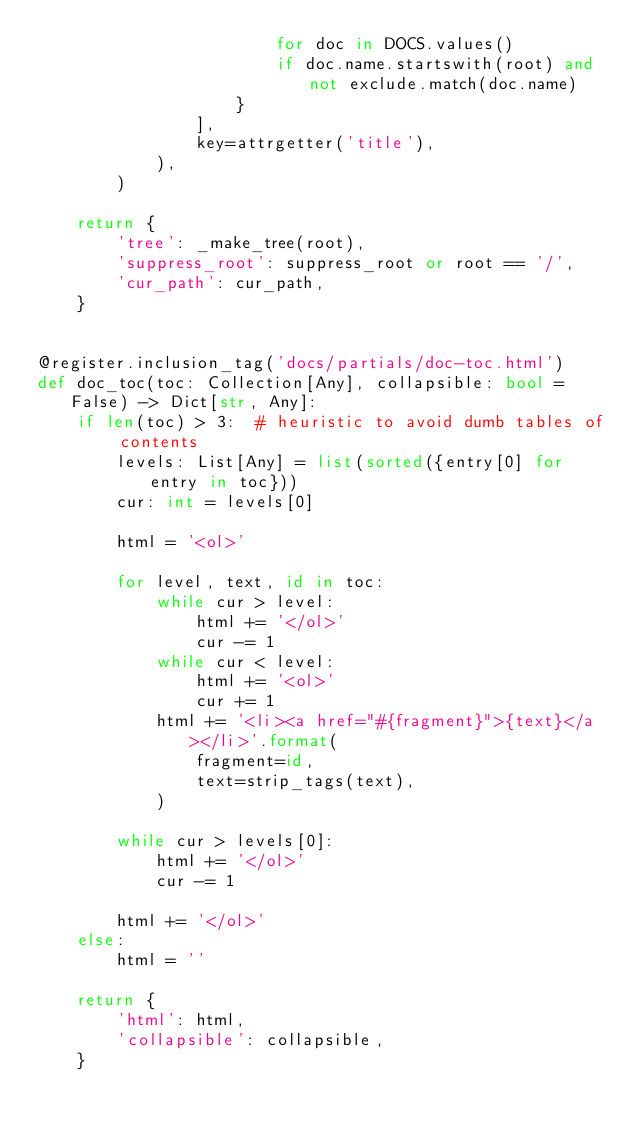<code> <loc_0><loc_0><loc_500><loc_500><_Python_>                        for doc in DOCS.values()
                        if doc.name.startswith(root) and not exclude.match(doc.name)
                    }
                ],
                key=attrgetter('title'),
            ),
        )

    return {
        'tree': _make_tree(root),
        'suppress_root': suppress_root or root == '/',
        'cur_path': cur_path,
    }


@register.inclusion_tag('docs/partials/doc-toc.html')
def doc_toc(toc: Collection[Any], collapsible: bool = False) -> Dict[str, Any]:
    if len(toc) > 3:  # heuristic to avoid dumb tables of contents
        levels: List[Any] = list(sorted({entry[0] for entry in toc}))
        cur: int = levels[0]

        html = '<ol>'

        for level, text, id in toc:
            while cur > level:
                html += '</ol>'
                cur -= 1
            while cur < level:
                html += '<ol>'
                cur += 1
            html += '<li><a href="#{fragment}">{text}</a></li>'.format(
                fragment=id,
                text=strip_tags(text),
            )

        while cur > levels[0]:
            html += '</ol>'
            cur -= 1

        html += '</ol>'
    else:
        html = ''

    return {
        'html': html,
        'collapsible': collapsible,
    }
</code> 